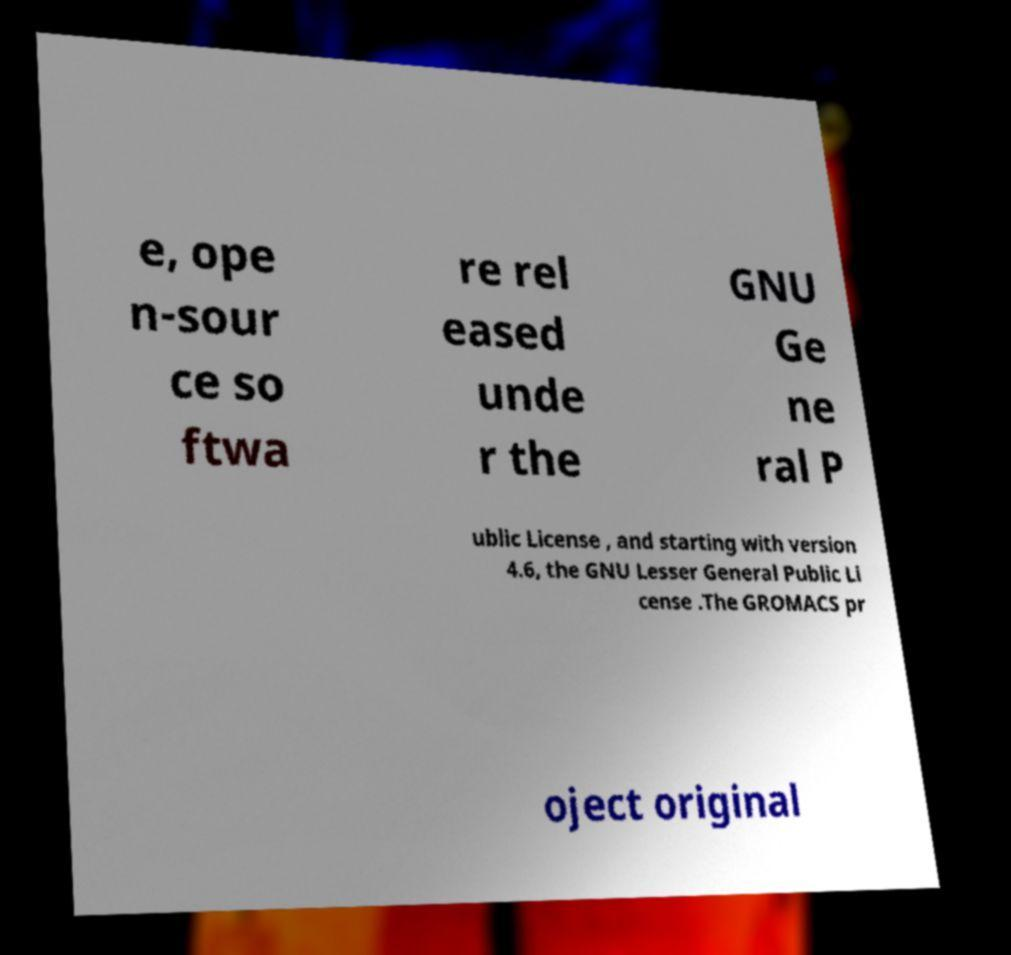Could you assist in decoding the text presented in this image and type it out clearly? e, ope n-sour ce so ftwa re rel eased unde r the GNU Ge ne ral P ublic License , and starting with version 4.6, the GNU Lesser General Public Li cense .The GROMACS pr oject original 